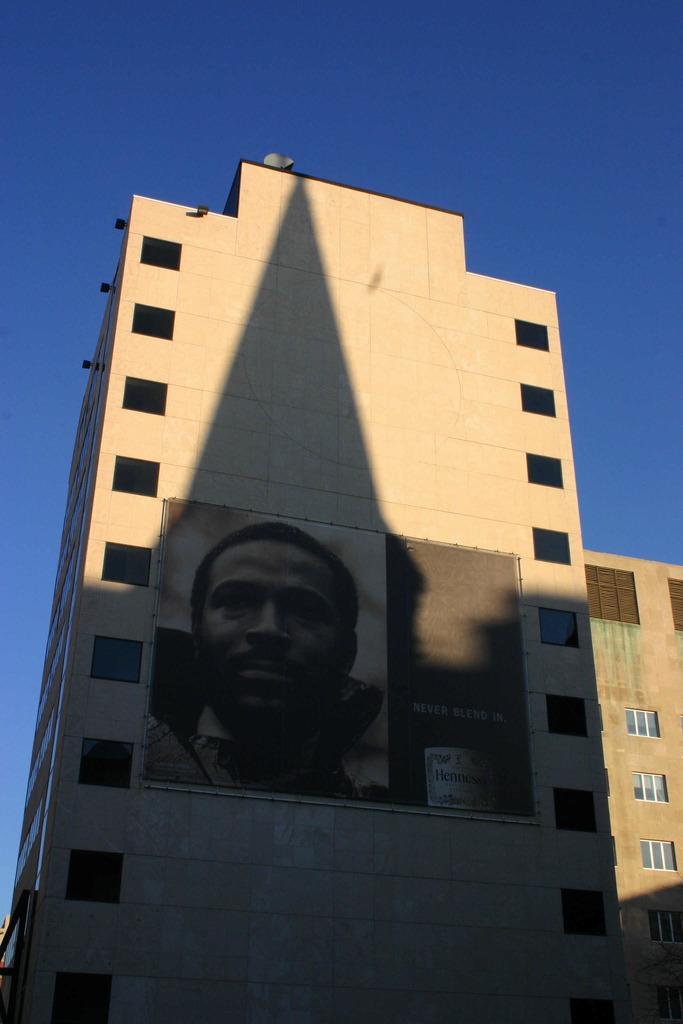Could you give a brief overview of what you see in this image? In this picture, we see a building in grey color. It has glass windows. In the middle, we see a banner or a poster of the man is pasted on the wall. In the background, we see the sky, which is blue in color. It is a sunny day. 